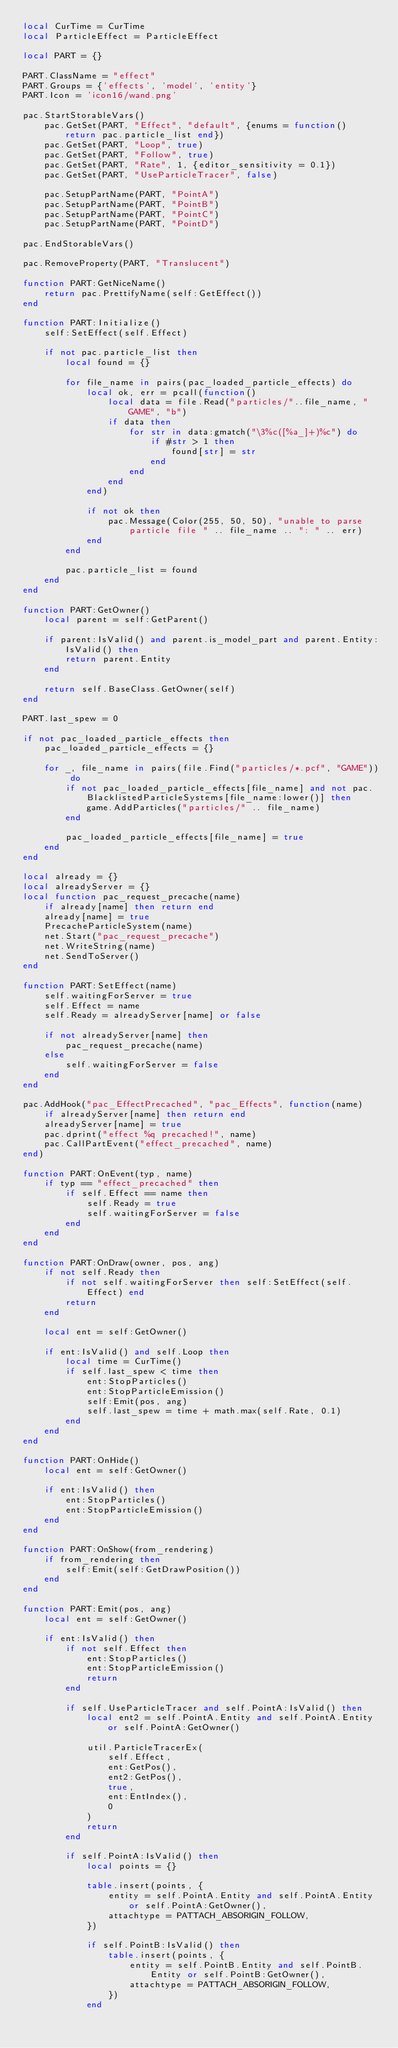<code> <loc_0><loc_0><loc_500><loc_500><_Lua_>local CurTime = CurTime
local ParticleEffect = ParticleEffect

local PART = {}

PART.ClassName = "effect"
PART.Groups = {'effects', 'model', 'entity'}
PART.Icon = 'icon16/wand.png'

pac.StartStorableVars()
	pac.GetSet(PART, "Effect", "default", {enums = function() return pac.particle_list end})
	pac.GetSet(PART, "Loop", true)
	pac.GetSet(PART, "Follow", true)
	pac.GetSet(PART, "Rate", 1, {editor_sensitivity = 0.1})
	pac.GetSet(PART, "UseParticleTracer", false)

	pac.SetupPartName(PART, "PointA")
	pac.SetupPartName(PART, "PointB")
	pac.SetupPartName(PART, "PointC")
	pac.SetupPartName(PART, "PointD")

pac.EndStorableVars()

pac.RemoveProperty(PART, "Translucent")

function PART:GetNiceName()
	return pac.PrettifyName(self:GetEffect())
end

function PART:Initialize()
	self:SetEffect(self.Effect)

	if not pac.particle_list then
		local found = {}

		for file_name in pairs(pac_loaded_particle_effects) do
			local ok, err = pcall(function()
				local data = file.Read("particles/"..file_name, "GAME", "b")
				if data then
					for str in data:gmatch("\3%c([%a_]+)%c") do
						if #str > 1 then
							found[str] = str
						end
					end
				end
			end)

			if not ok then
				pac.Message(Color(255, 50, 50), "unable to parse particle file " .. file_name .. ": " .. err)
			end
		end

		pac.particle_list = found
	end
end

function PART:GetOwner()
	local parent = self:GetParent()

	if parent:IsValid() and parent.is_model_part and parent.Entity:IsValid() then
		return parent.Entity
	end

	return self.BaseClass.GetOwner(self)
end

PART.last_spew = 0

if not pac_loaded_particle_effects then
	pac_loaded_particle_effects = {}

	for _, file_name in pairs(file.Find("particles/*.pcf", "GAME")) do
		if not pac_loaded_particle_effects[file_name] and not pac.BlacklistedParticleSystems[file_name:lower()] then
			game.AddParticles("particles/" .. file_name)
		end

		pac_loaded_particle_effects[file_name] = true
	end
end

local already = {}
local alreadyServer = {}
local function pac_request_precache(name)
	if already[name] then return end
	already[name] = true
	PrecacheParticleSystem(name)
	net.Start("pac_request_precache")
	net.WriteString(name)
	net.SendToServer()
end

function PART:SetEffect(name)
	self.waitingForServer = true
	self.Effect = name
	self.Ready = alreadyServer[name] or false

	if not alreadyServer[name] then
		pac_request_precache(name)
	else
		self.waitingForServer = false
	end
end

pac.AddHook("pac_EffectPrecached", "pac_Effects", function(name)
	if alreadyServer[name] then return end
	alreadyServer[name] = true
	pac.dprint("effect %q precached!", name)
	pac.CallPartEvent("effect_precached", name)
end)

function PART:OnEvent(typ, name)
	if typ == "effect_precached" then
		if self.Effect == name then
			self.Ready = true
			self.waitingForServer = false
		end
	end
end

function PART:OnDraw(owner, pos, ang)
	if not self.Ready then
		if not self.waitingForServer then self:SetEffect(self.Effect) end
		return
	end

	local ent = self:GetOwner()

	if ent:IsValid() and self.Loop then
		local time = CurTime()
		if self.last_spew < time then
			ent:StopParticles()
			ent:StopParticleEmission()
			self:Emit(pos, ang)
			self.last_spew = time + math.max(self.Rate, 0.1)
		end
	end
end

function PART:OnHide()
	local ent = self:GetOwner()

	if ent:IsValid() then
		ent:StopParticles()
		ent:StopParticleEmission()
	end
end

function PART:OnShow(from_rendering)
	if from_rendering then
		self:Emit(self:GetDrawPosition())
	end
end

function PART:Emit(pos, ang)
	local ent = self:GetOwner()

	if ent:IsValid() then
		if not self.Effect then
			ent:StopParticles()
			ent:StopParticleEmission()
			return
		end

		if self.UseParticleTracer and self.PointA:IsValid() then
			local ent2 = self.PointA.Entity and self.PointA.Entity or self.PointA:GetOwner()

			util.ParticleTracerEx(
				self.Effect,
				ent:GetPos(),
				ent2:GetPos(),
				true,
				ent:EntIndex(),
				0
			)
			return
		end

		if self.PointA:IsValid() then
			local points = {}

			table.insert(points, {
				entity = self.PointA.Entity and self.PointA.Entity or self.PointA:GetOwner(),
				attachtype = PATTACH_ABSORIGIN_FOLLOW,
			})

			if self.PointB:IsValid() then
				table.insert(points, {
					entity = self.PointB.Entity and self.PointB.Entity or self.PointB:GetOwner(),
					attachtype = PATTACH_ABSORIGIN_FOLLOW,
				})
			end
</code> 